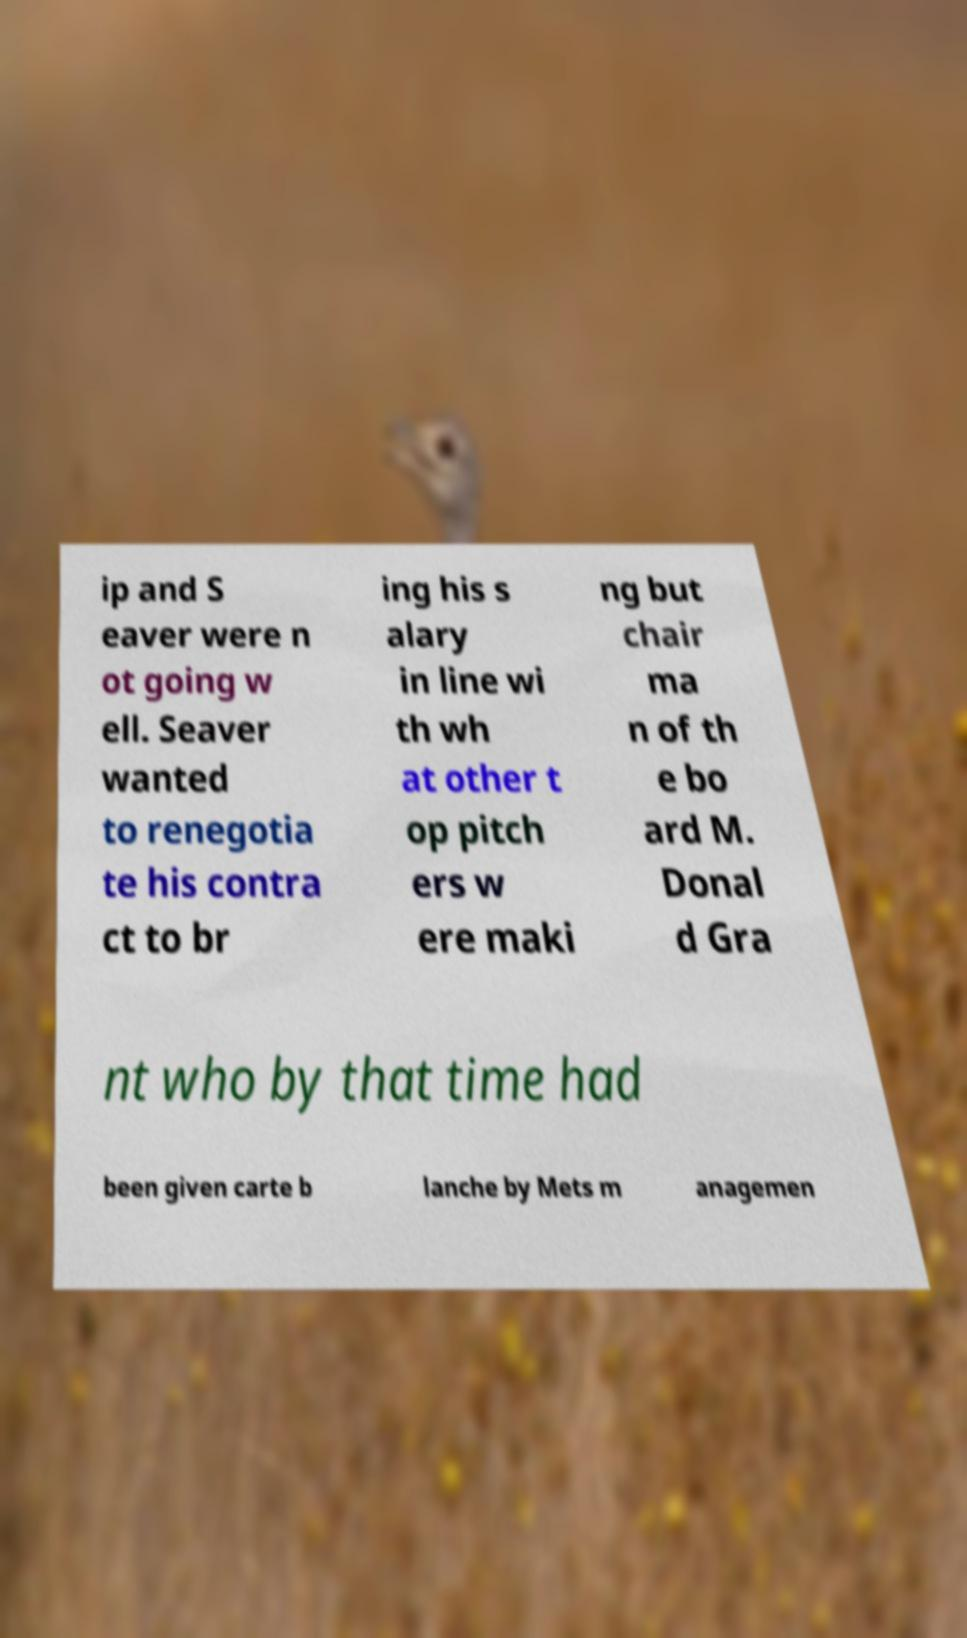Please read and relay the text visible in this image. What does it say? ip and S eaver were n ot going w ell. Seaver wanted to renegotia te his contra ct to br ing his s alary in line wi th wh at other t op pitch ers w ere maki ng but chair ma n of th e bo ard M. Donal d Gra nt who by that time had been given carte b lanche by Mets m anagemen 